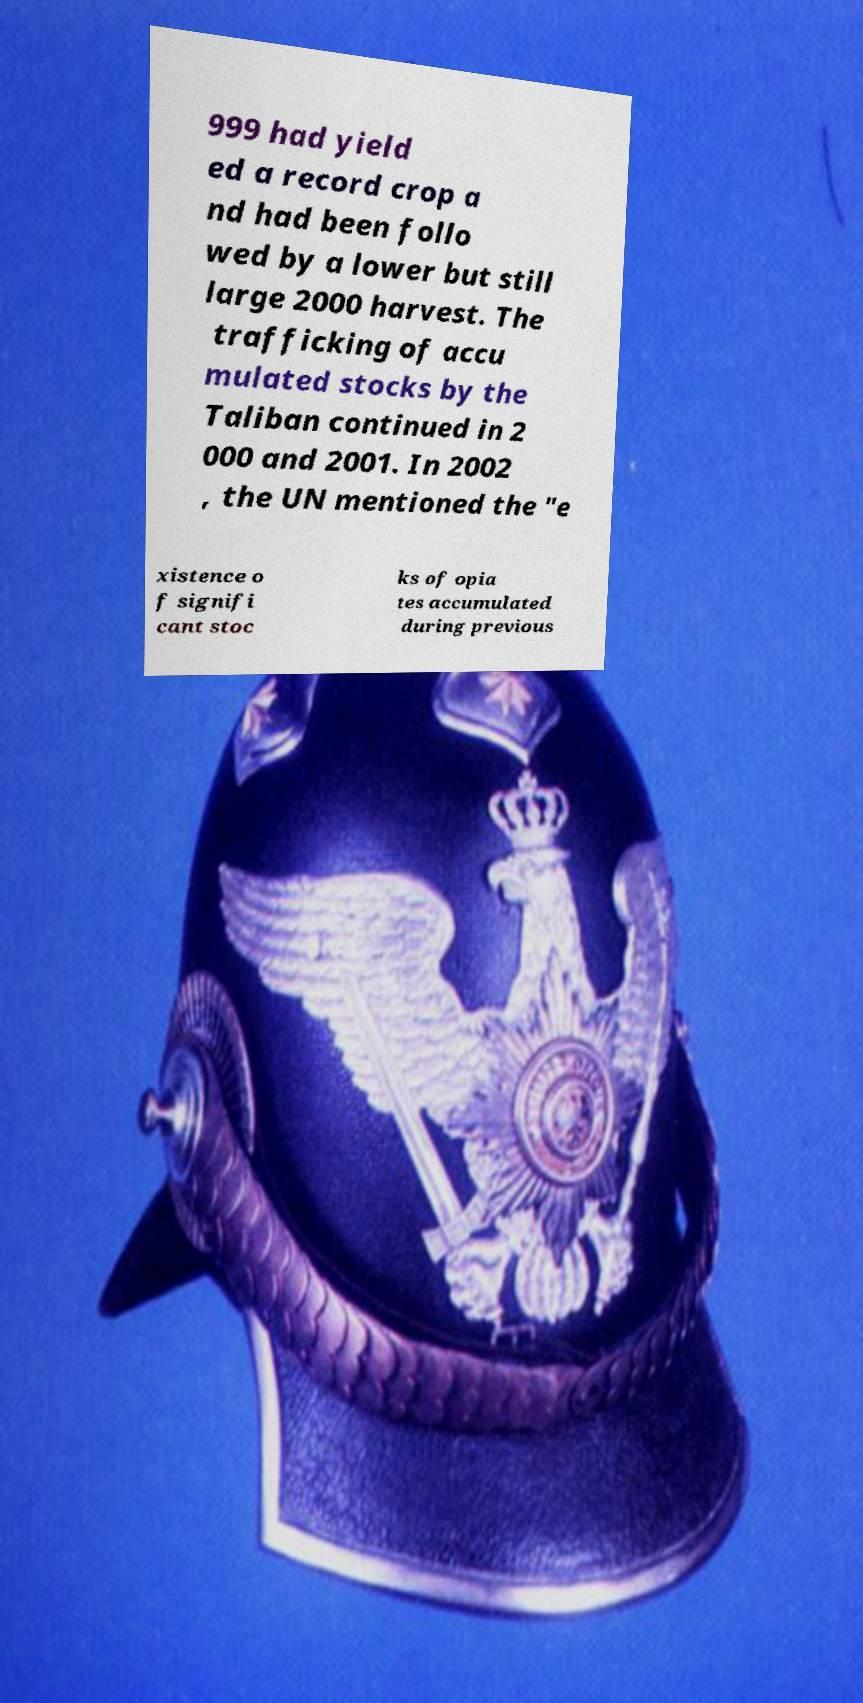For documentation purposes, I need the text within this image transcribed. Could you provide that? 999 had yield ed a record crop a nd had been follo wed by a lower but still large 2000 harvest. The trafficking of accu mulated stocks by the Taliban continued in 2 000 and 2001. In 2002 , the UN mentioned the "e xistence o f signifi cant stoc ks of opia tes accumulated during previous 